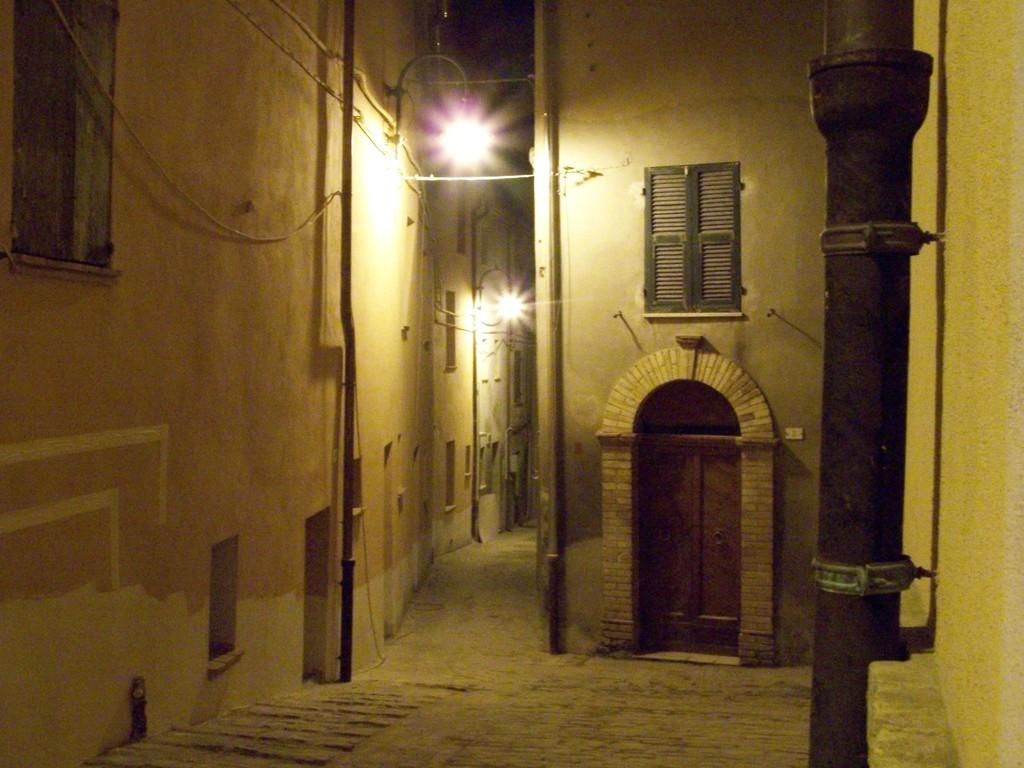What type of structures can be seen in the image? There are walls in the image. What other objects can be seen in the image? There are ropes, poles, pipelines, street poles, and street lights visible in the image. Can you describe the door in the image? There is a door in the image. What might the ropes and poles be used for in the image? The ropes and poles might be used for supporting or connecting other structures or objects in the image. Where is the pot located in the image? There is no pot present in the image. Can you describe the ball being played with in the image? There is no ball present in the image. 